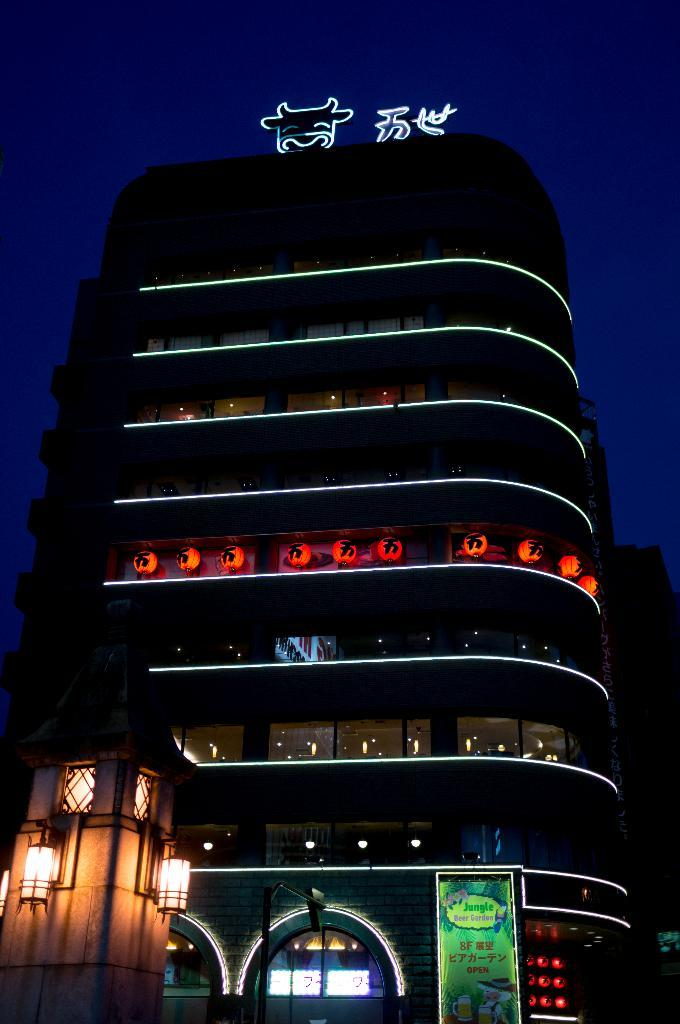What type of structure can be seen in the image? There is a building and a house in the image. What is written or displayed on a board in the image? There is a board with text in the image. What can be seen illuminated in the image? There are lights visible in the image. What is on top of the building in the image? There are objects on top of the building. What is visible in the sky in the image? The sky is visible in the image. What is the chance of the wristwatch being visible on the building in the image? There is no wristwatch present in the image, so it is not possible to determine the chance of it being visible. 